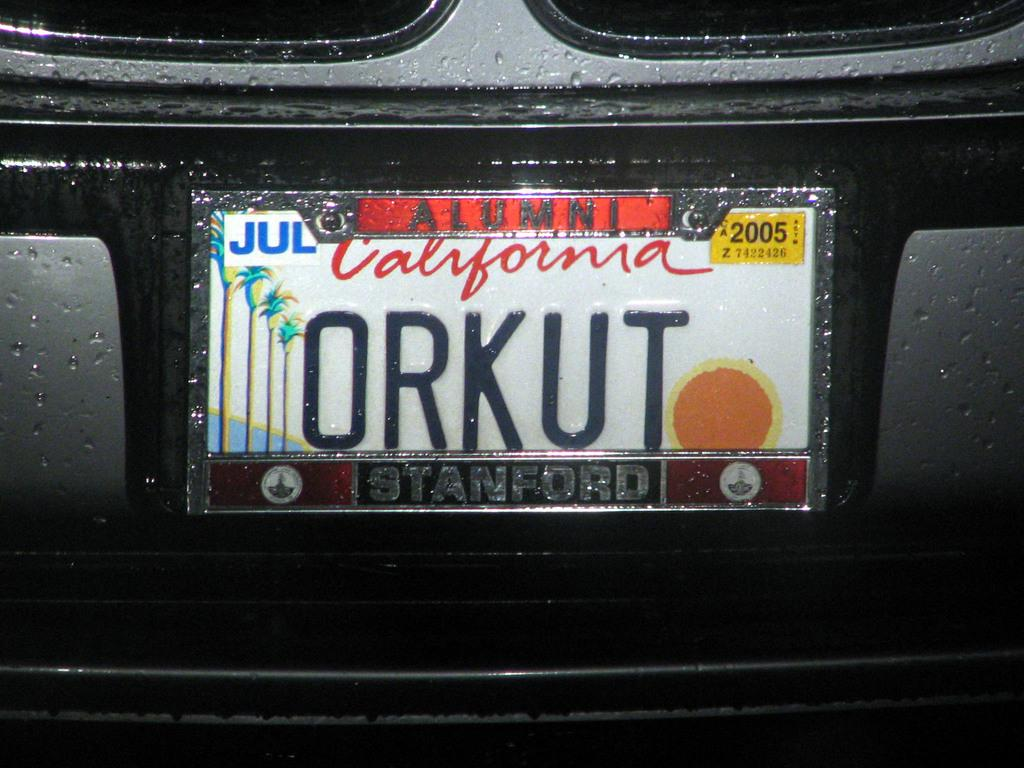Provide a one-sentence caption for the provided image. A picture California license  plate that says ORKUT. 